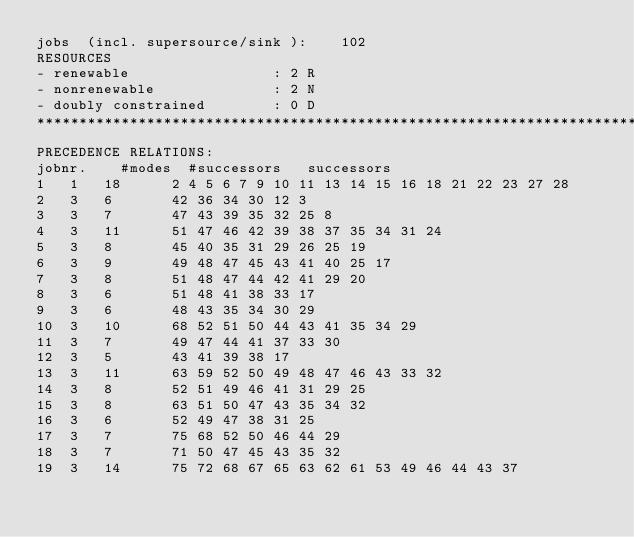Convert code to text. <code><loc_0><loc_0><loc_500><loc_500><_ObjectiveC_>jobs  (incl. supersource/sink ):	102
RESOURCES
- renewable                 : 2 R
- nonrenewable              : 2 N
- doubly constrained        : 0 D
************************************************************************
PRECEDENCE RELATIONS:
jobnr.    #modes  #successors   successors
1	1	18		2 4 5 6 7 9 10 11 13 14 15 16 18 21 22 23 27 28 
2	3	6		42 36 34 30 12 3 
3	3	7		47 43 39 35 32 25 8 
4	3	11		51 47 46 42 39 38 37 35 34 31 24 
5	3	8		45 40 35 31 29 26 25 19 
6	3	9		49 48 47 45 43 41 40 25 17 
7	3	8		51 48 47 44 42 41 29 20 
8	3	6		51 48 41 38 33 17 
9	3	6		48 43 35 34 30 29 
10	3	10		68 52 51 50 44 43 41 35 34 29 
11	3	7		49 47 44 41 37 33 30 
12	3	5		43 41 39 38 17 
13	3	11		63 59 52 50 49 48 47 46 43 33 32 
14	3	8		52 51 49 46 41 31 29 25 
15	3	8		63 51 50 47 43 35 34 32 
16	3	6		52 49 47 38 31 25 
17	3	7		75 68 52 50 46 44 29 
18	3	7		71 50 47 45 43 35 32 
19	3	14		75 72 68 67 65 63 62 61 53 49 46 44 43 37 </code> 